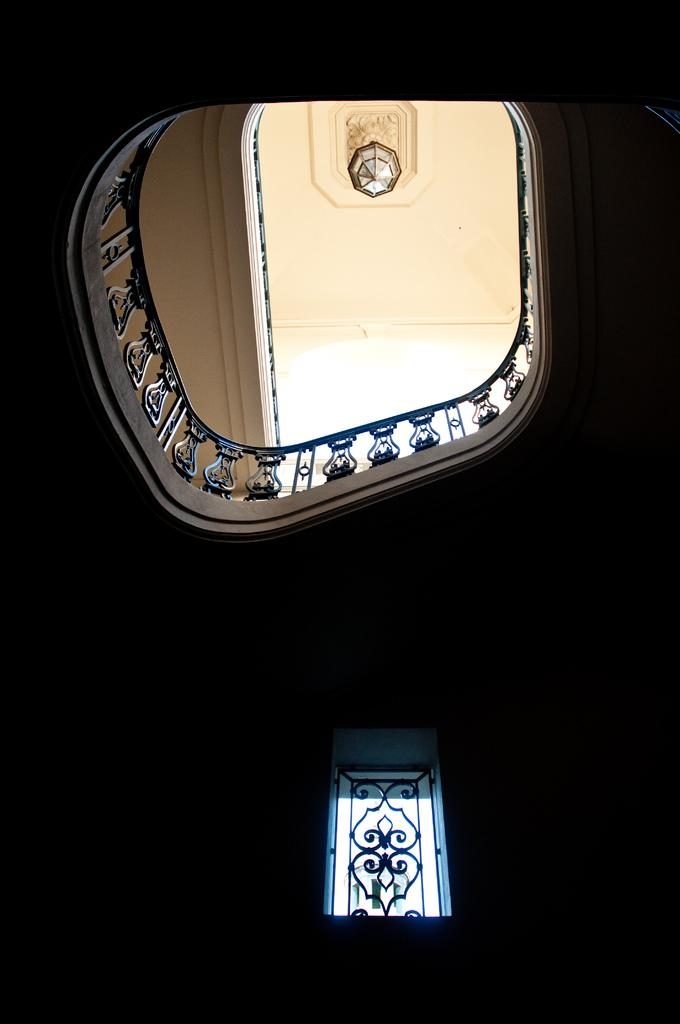What architectural feature can be seen in the image? There is a window in the image. What safety feature is present in the image? There is a railing in the image. What structure is visible in the image? There is a roof in the image. What type of lighting fixture is attached to the roof? A chandelier is attached to the roof. What vegetable is being used as a start for a race in the image? There is no race or vegetable present in the image. 